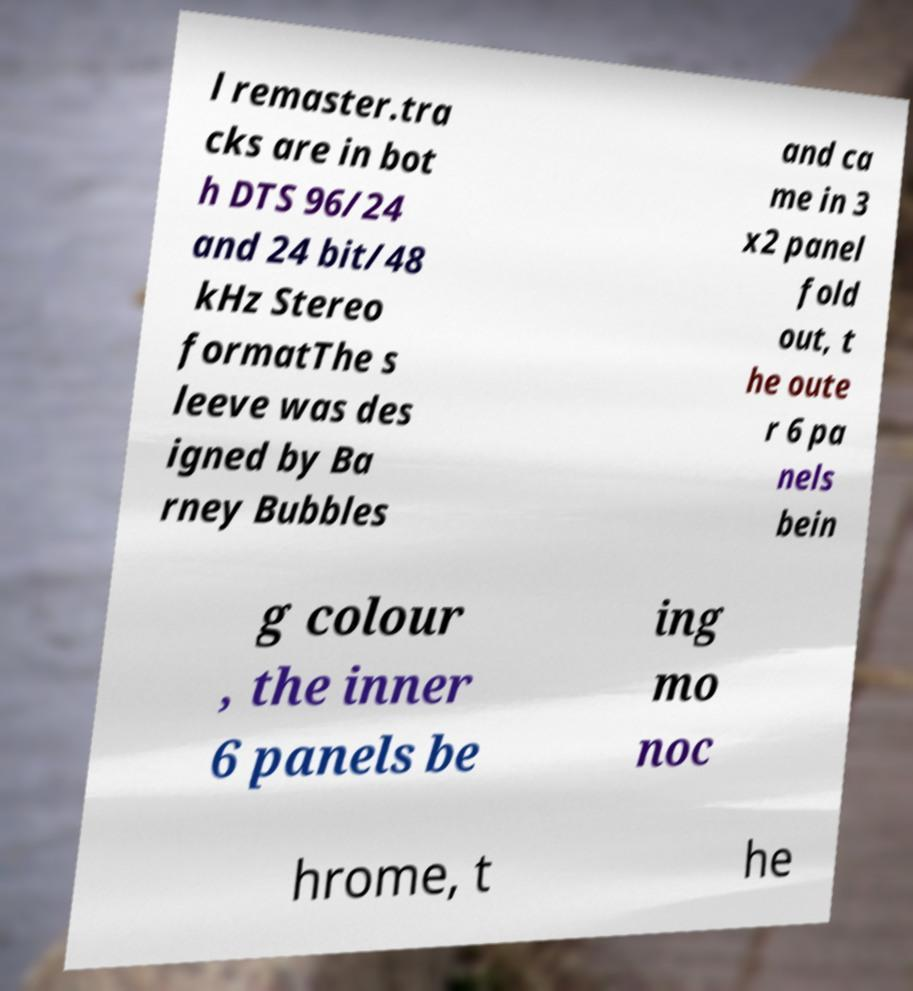Please read and relay the text visible in this image. What does it say? l remaster.tra cks are in bot h DTS 96/24 and 24 bit/48 kHz Stereo formatThe s leeve was des igned by Ba rney Bubbles and ca me in 3 x2 panel fold out, t he oute r 6 pa nels bein g colour , the inner 6 panels be ing mo noc hrome, t he 